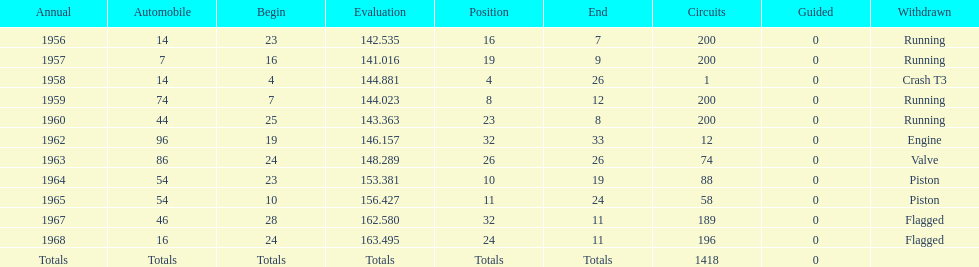How many times did he finish all 200 laps? 4. 